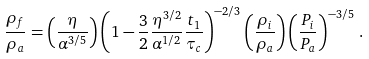<formula> <loc_0><loc_0><loc_500><loc_500>\frac { \rho _ { f } } { \rho _ { a } } = \left ( \frac { \eta } { \alpha ^ { 3 / 5 } } \right ) \left ( 1 - \frac { 3 } { 2 } \frac { \eta ^ { 3 / 2 } } { \alpha ^ { 1 / 2 } } \frac { t _ { 1 } } { \tau _ { c } } \right ) ^ { - 2 / 3 } \left ( \frac { \rho _ { i } } { \rho _ { a } } \right ) \left ( \frac { P _ { i } } { P _ { a } } \right ) ^ { - 3 / 5 } \, .</formula> 